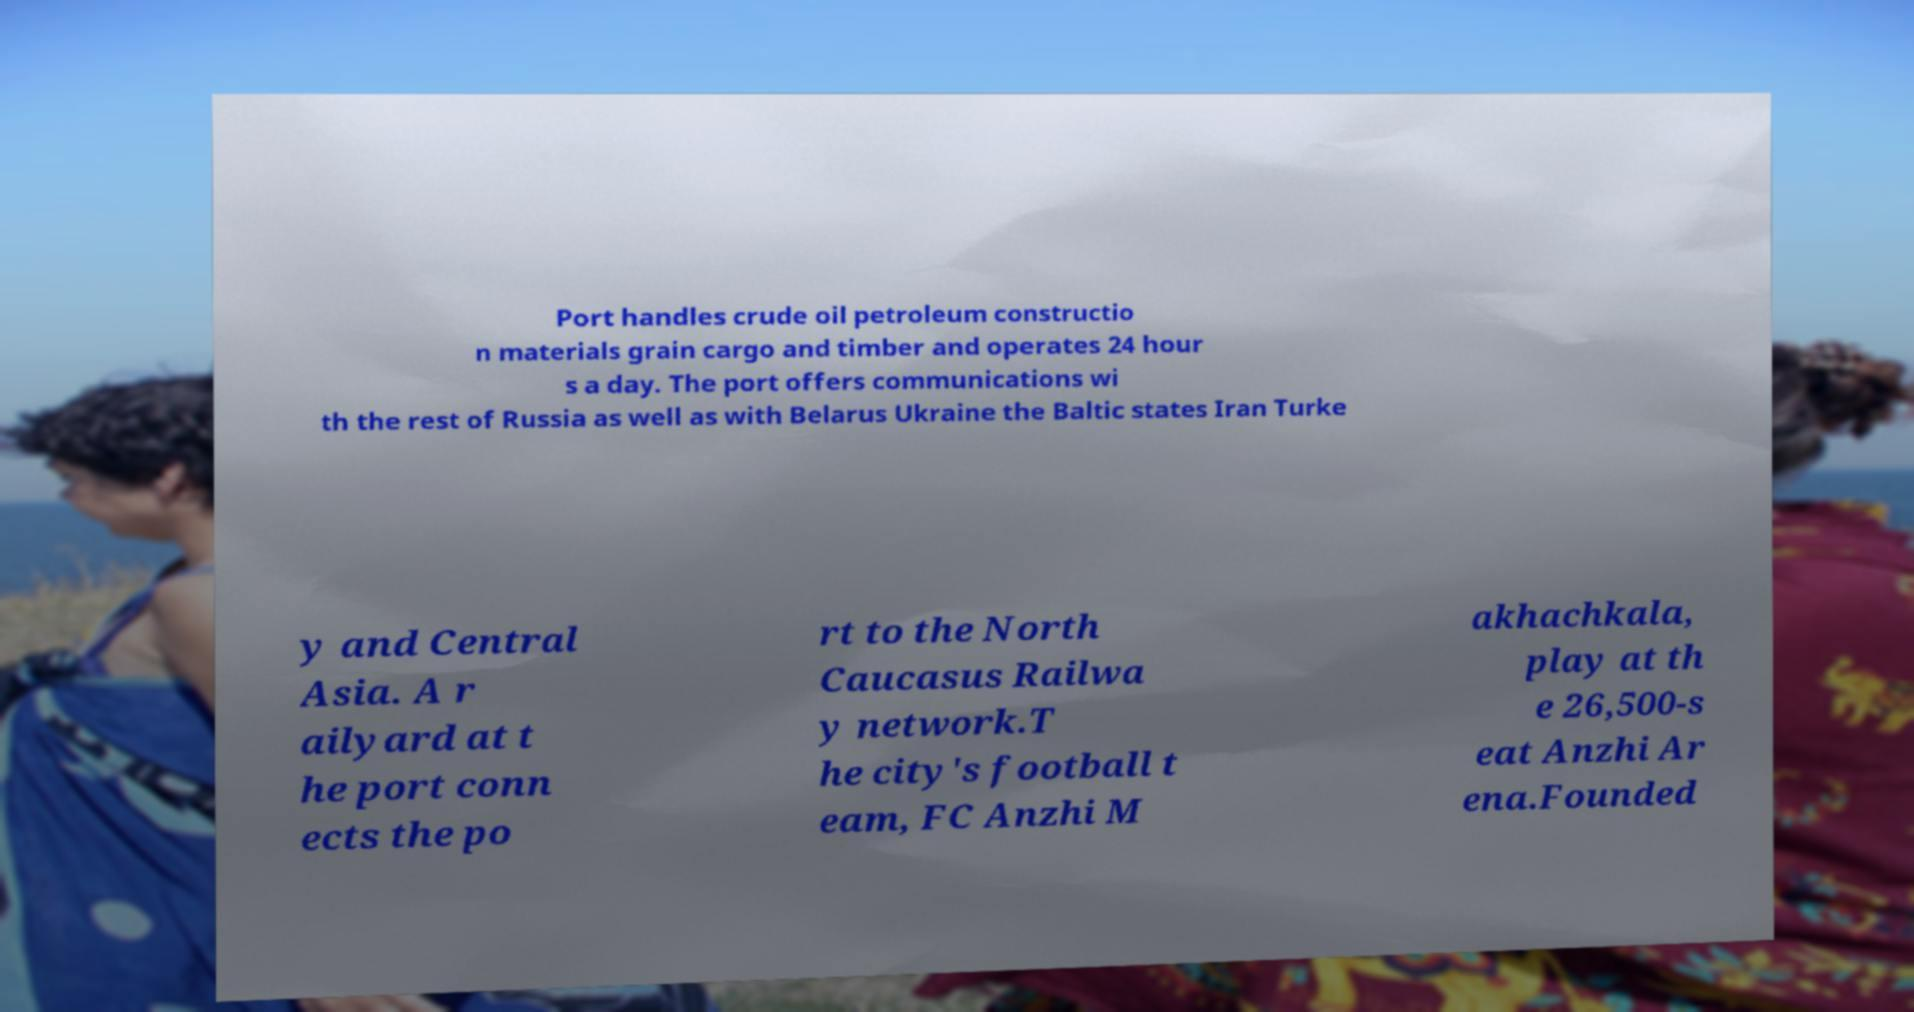Could you extract and type out the text from this image? Port handles crude oil petroleum constructio n materials grain cargo and timber and operates 24 hour s a day. The port offers communications wi th the rest of Russia as well as with Belarus Ukraine the Baltic states Iran Turke y and Central Asia. A r ailyard at t he port conn ects the po rt to the North Caucasus Railwa y network.T he city's football t eam, FC Anzhi M akhachkala, play at th e 26,500-s eat Anzhi Ar ena.Founded 